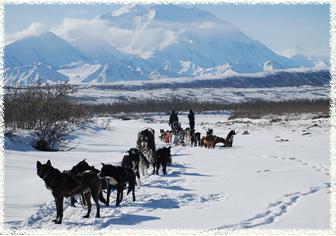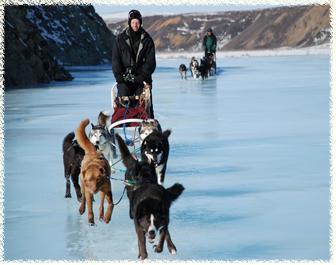The first image is the image on the left, the second image is the image on the right. Considering the images on both sides, is "An image shows a sled dog team heading rightward and downward." valid? Answer yes or no. No. The first image is the image on the left, the second image is the image on the right. For the images displayed, is the sentence "All of the humans in the right photo are wearing red jackets." factually correct? Answer yes or no. No. The first image is the image on the left, the second image is the image on the right. Evaluate the accuracy of this statement regarding the images: "The right image shows a dog sled team heading straight toward the camera.". Is it true? Answer yes or no. Yes. 